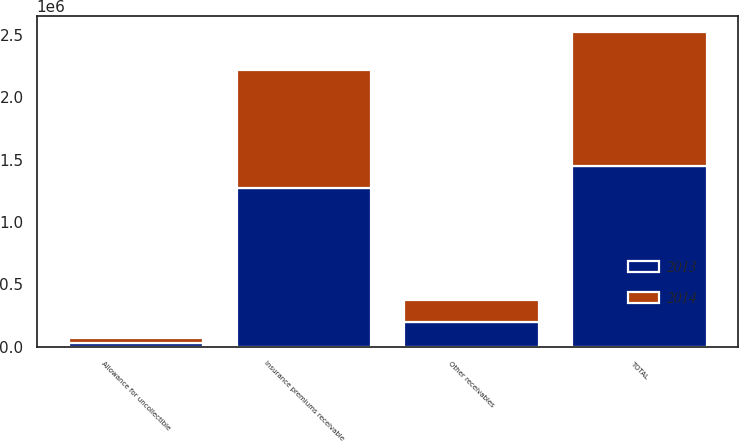Convert chart. <chart><loc_0><loc_0><loc_500><loc_500><stacked_bar_chart><ecel><fcel>Insurance premiums receivable<fcel>Other receivables<fcel>Allowance for uncollectible<fcel>TOTAL<nl><fcel>2013<fcel>1.27544e+06<fcel>201758<fcel>31568<fcel>1.44563e+06<nl><fcel>2014<fcel>941460<fcel>175357<fcel>36646<fcel>1.08017e+06<nl></chart> 